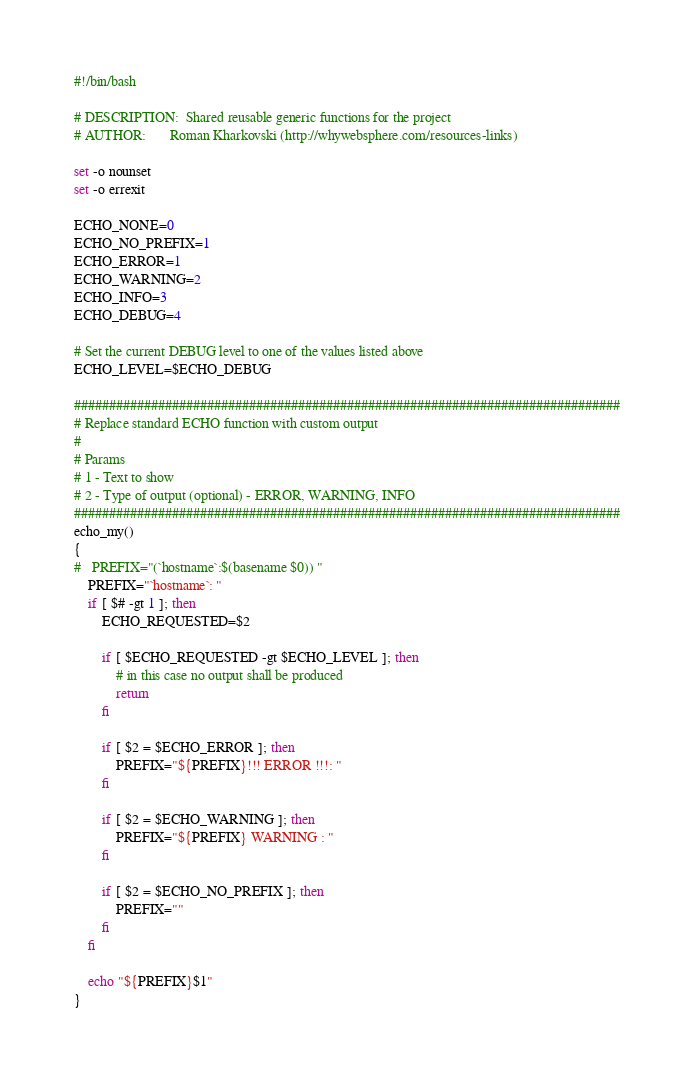<code> <loc_0><loc_0><loc_500><loc_500><_Bash_>#!/bin/bash

# DESCRIPTION:	Shared reusable generic functions for the project
# AUTHOR:   	Roman Kharkovski (http://whywebsphere.com/resources-links)

set -o nounset
set -o errexit

ECHO_NONE=0
ECHO_NO_PREFIX=1
ECHO_ERROR=1
ECHO_WARNING=2
ECHO_INFO=3
ECHO_DEBUG=4

# Set the current DEBUG level to one of the values listed above
ECHO_LEVEL=$ECHO_DEBUG

##############################################################################
# Replace standard ECHO function with custom output
#
# Params
# 1 - Text to show
# 2 - Type of output (optional) - ERROR, WARNING, INFO
##############################################################################
echo_my()
{
#	PREFIX="(`hostname`:$(basename $0)) "
	PREFIX="`hostname`: "
	if [ $# -gt 1 ]; then
		ECHO_REQUESTED=$2
		
		if [ $ECHO_REQUESTED -gt $ECHO_LEVEL ]; then
			# in this case no output shall be produced
			return
		fi
	
		if [ $2 = $ECHO_ERROR ]; then
			PREFIX="${PREFIX}!!! ERROR !!!: "
		fi

		if [ $2 = $ECHO_WARNING ]; then
			PREFIX="${PREFIX} WARNING : "
		fi

		if [ $2 = $ECHO_NO_PREFIX ]; then
			PREFIX=""
		fi
	fi

	echo "${PREFIX}$1"
}</code> 